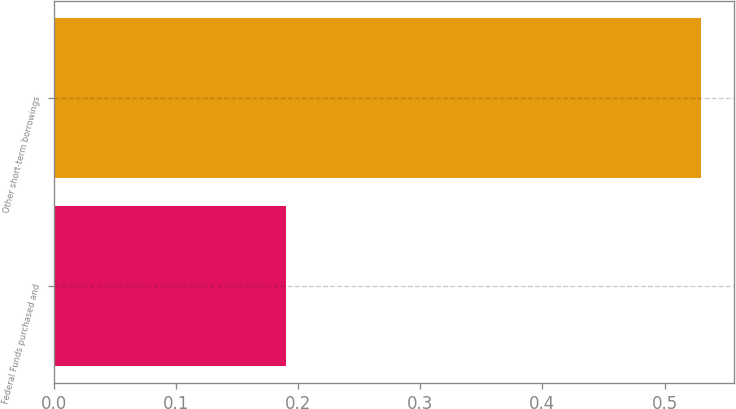<chart> <loc_0><loc_0><loc_500><loc_500><bar_chart><fcel>Federal Funds purchased and<fcel>Other short-term borrowings<nl><fcel>0.19<fcel>0.53<nl></chart> 